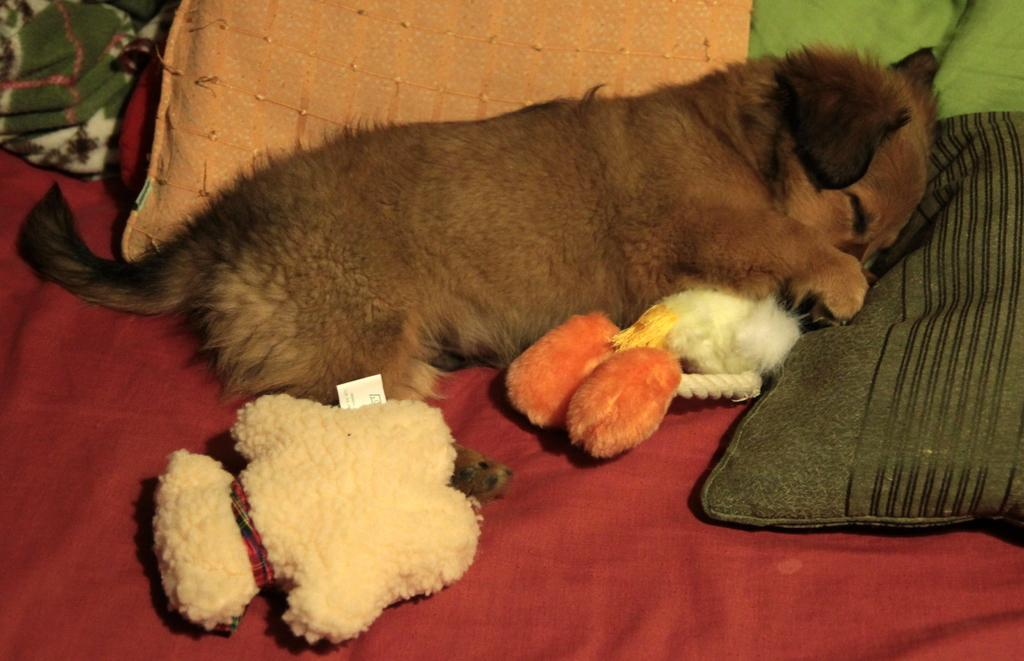What type of animal is in the image? There is a dog in the image. What is the dog doing in the image? The dog is sleeping. Where is the dog located in the image? The dog is in the center of the image. What items are beside the dog? There are toys and a pillow beside the dog. What surface is the dog sleeping on? The dog appears to be sleeping on a bed. What type of wrench is the dog using to fix the channel in the image? There is no wrench or channel present in the image; it features a dog sleeping with toys and a pillow beside it. 